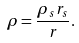Convert formula to latex. <formula><loc_0><loc_0><loc_500><loc_500>\rho = \frac { \rho _ { s } r _ { s } } { r } .</formula> 